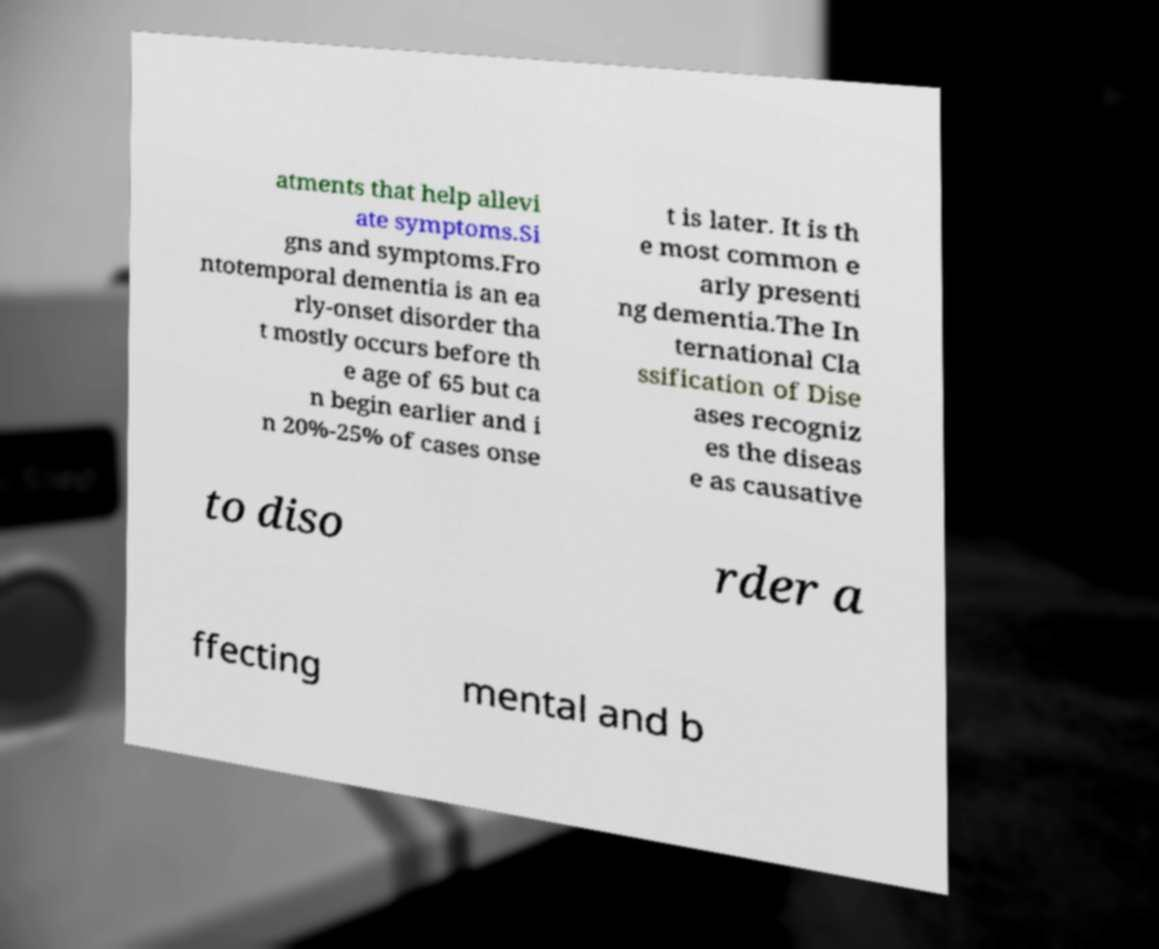Can you accurately transcribe the text from the provided image for me? atments that help allevi ate symptoms.Si gns and symptoms.Fro ntotemporal dementia is an ea rly-onset disorder tha t mostly occurs before th e age of 65 but ca n begin earlier and i n 20%-25% of cases onse t is later. It is th e most common e arly presenti ng dementia.The In ternational Cla ssification of Dise ases recogniz es the diseas e as causative to diso rder a ffecting mental and b 